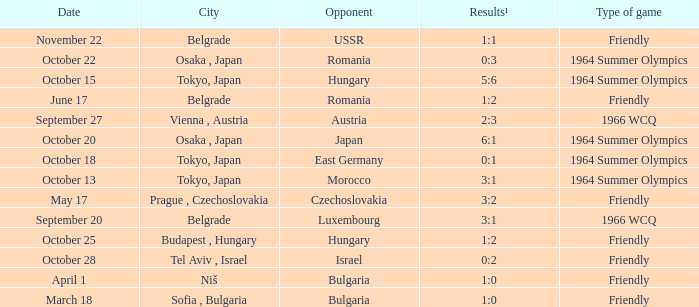What day were the results 3:2? May 17. Could you parse the entire table as a dict? {'header': ['Date', 'City', 'Opponent', 'Results¹', 'Type of game'], 'rows': [['November 22', 'Belgrade', 'USSR', '1:1', 'Friendly'], ['October 22', 'Osaka , Japan', 'Romania', '0:3', '1964 Summer Olympics'], ['October 15', 'Tokyo, Japan', 'Hungary', '5:6', '1964 Summer Olympics'], ['June 17', 'Belgrade', 'Romania', '1:2', 'Friendly'], ['September 27', 'Vienna , Austria', 'Austria', '2:3', '1966 WCQ'], ['October 20', 'Osaka , Japan', 'Japan', '6:1', '1964 Summer Olympics'], ['October 18', 'Tokyo, Japan', 'East Germany', '0:1', '1964 Summer Olympics'], ['October 13', 'Tokyo, Japan', 'Morocco', '3:1', '1964 Summer Olympics'], ['May 17', 'Prague , Czechoslovakia', 'Czechoslovakia', '3:2', 'Friendly'], ['September 20', 'Belgrade', 'Luxembourg', '3:1', '1966 WCQ'], ['October 25', 'Budapest , Hungary', 'Hungary', '1:2', 'Friendly'], ['October 28', 'Tel Aviv , Israel', 'Israel', '0:2', 'Friendly'], ['April 1', 'Niš', 'Bulgaria', '1:0', 'Friendly'], ['March 18', 'Sofia , Bulgaria', 'Bulgaria', '1:0', 'Friendly']]} 